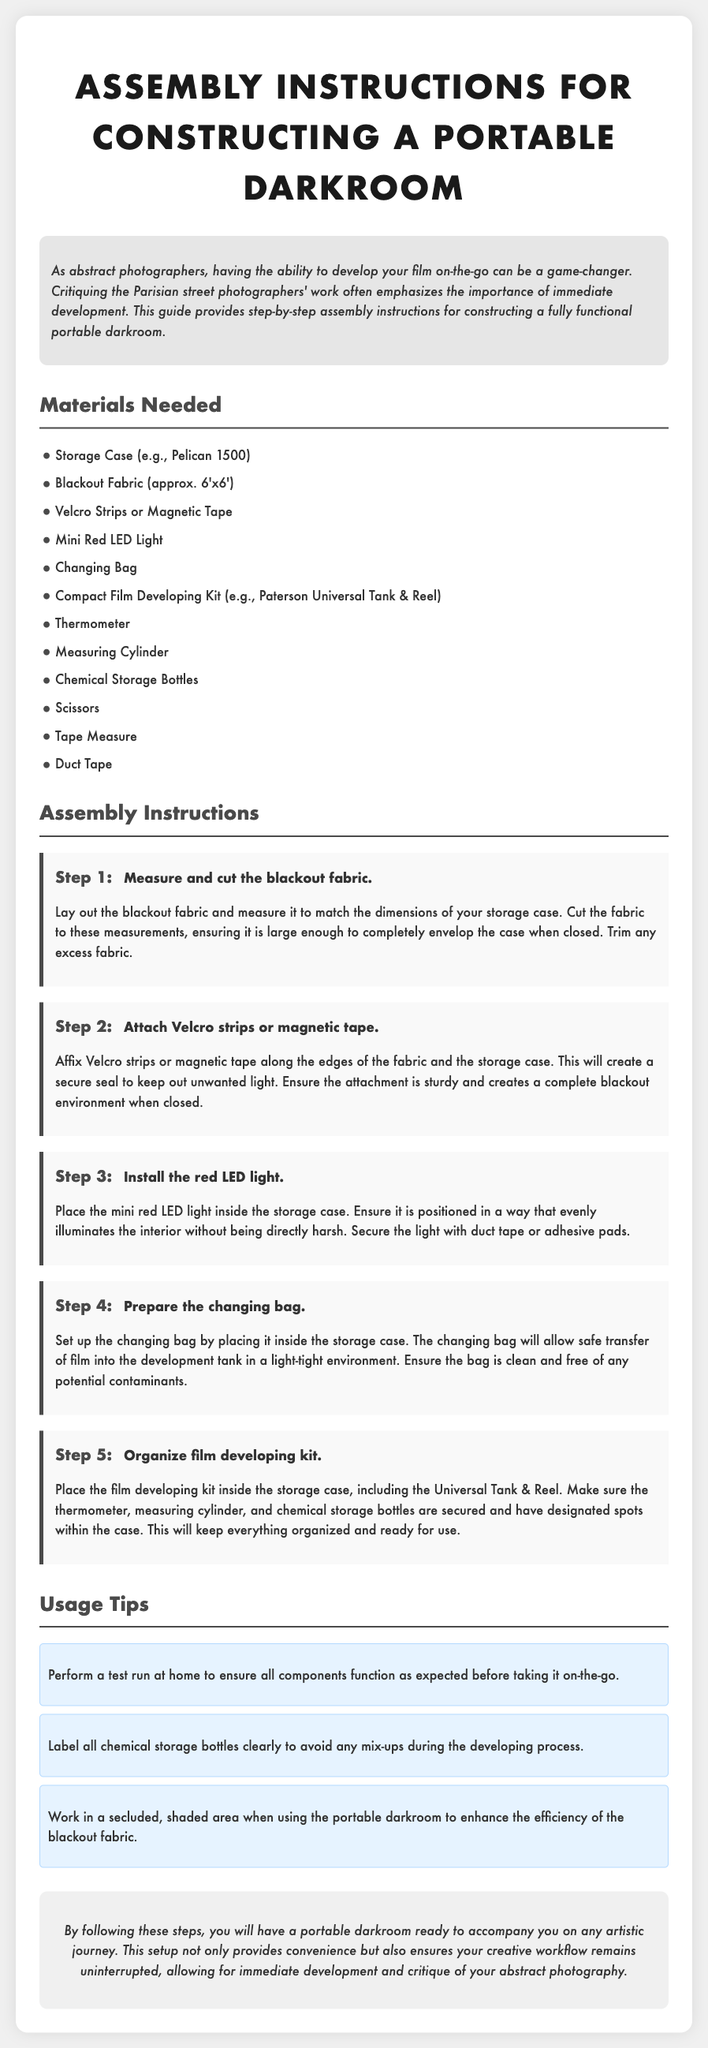What is the title of the document? The title is found in the header section of the document, which specifically states "Assembly Instructions for Constructing a Portable Darkroom."
Answer: Assembly Instructions for Constructing a Portable Darkroom How many steps are there in the assembly instructions? The number of steps can be counted in the "Assembly Instructions" section where each step is distinctly numbered. There are five steps listed.
Answer: 5 What is the size of the blackout fabric needed? The size of the blackout fabric is mentioned in the "Materials Needed" section of the document. It specifies "approx. 6'x6'."
Answer: approx. 6'x6' What should be done to ensure the portable darkroom is light-tight? This information can be inferred from the steps involving the use of Velcro strips or magnetic tape to secure the fabric around the storage case.
Answer: Attach Velcro strips or magnetic tape What is a recommended location for using the portable darkroom? The tips section suggests an ideal environment for using the setup, emphasizing a specific condition to enhance effectiveness.
Answer: Secluded, shaded area What type of light is suggested for the portable darkroom? The type of light is mentioned in Step 3, describing what should be installed in the case.
Answer: Mini Red LED Light Which kit is specified for film developing? The document refers to a specific development kit in the materials needed portion, providing the name of the kit that can be used.
Answer: Paterson Universal Tank & Reel What is the purpose of the changing bag? The purpose is outlined in the steps, indicating its specific role during the film developing process to maintain a light-tight environment.
Answer: Safe transfer of film into the development tank What action should be taken before using the portable darkroom? This is indicated in the tips section, discouraging usage until a certain condition is met to ensure readiness.
Answer: Perform a test run at home 